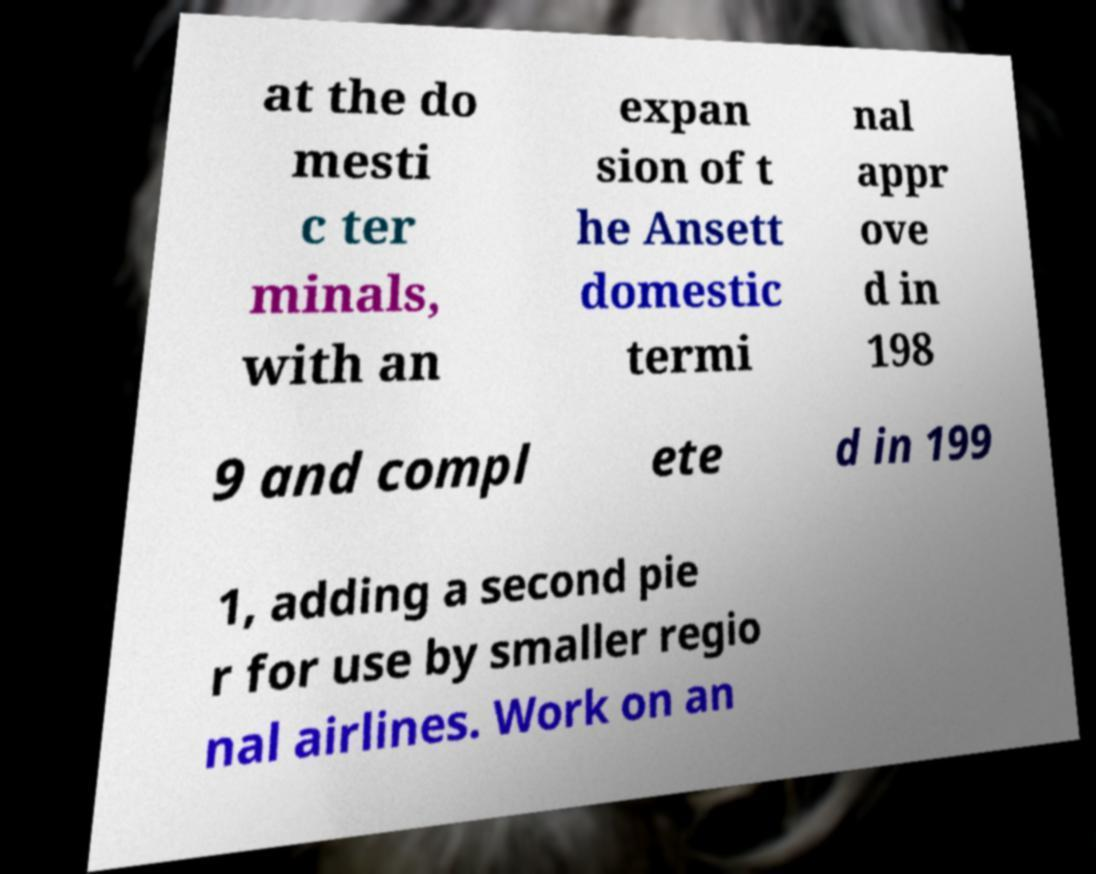Please read and relay the text visible in this image. What does it say? at the do mesti c ter minals, with an expan sion of t he Ansett domestic termi nal appr ove d in 198 9 and compl ete d in 199 1, adding a second pie r for use by smaller regio nal airlines. Work on an 